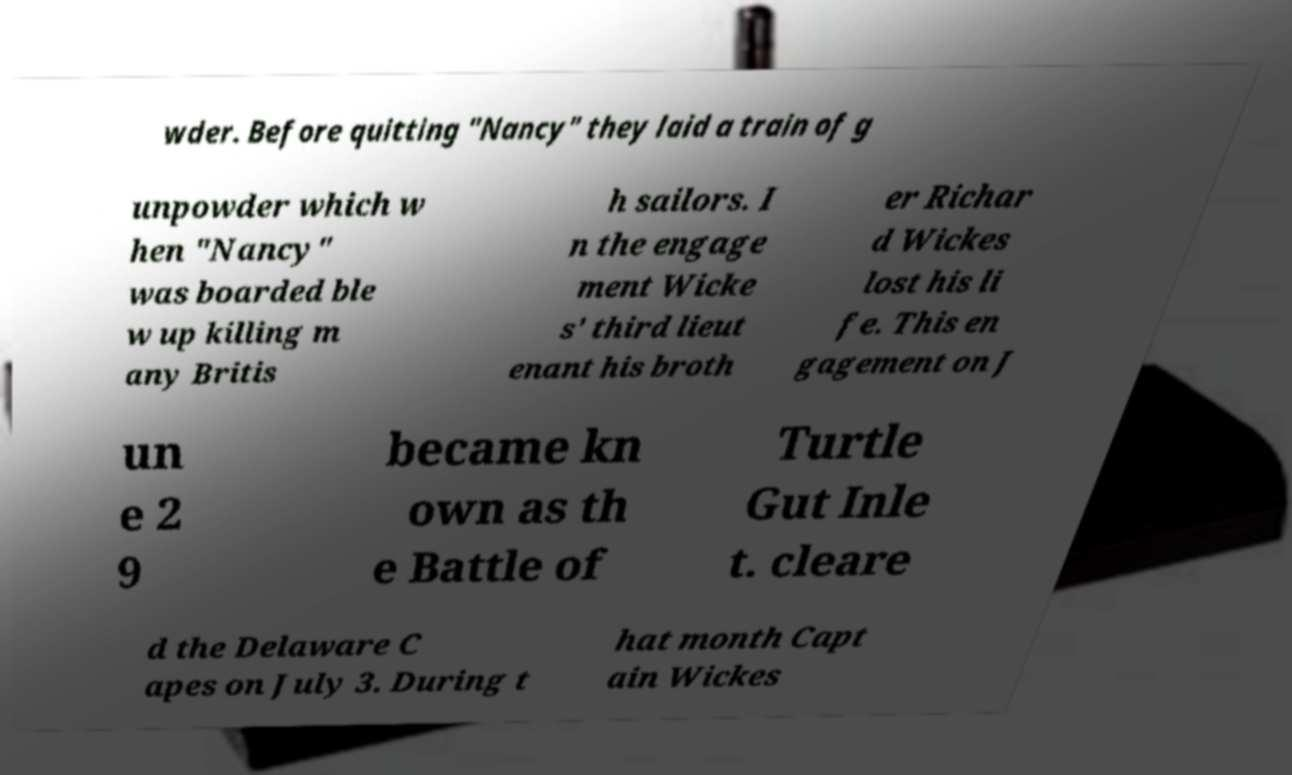Please identify and transcribe the text found in this image. wder. Before quitting "Nancy" they laid a train of g unpowder which w hen "Nancy" was boarded ble w up killing m any Britis h sailors. I n the engage ment Wicke s' third lieut enant his broth er Richar d Wickes lost his li fe. This en gagement on J un e 2 9 became kn own as th e Battle of Turtle Gut Inle t. cleare d the Delaware C apes on July 3. During t hat month Capt ain Wickes 